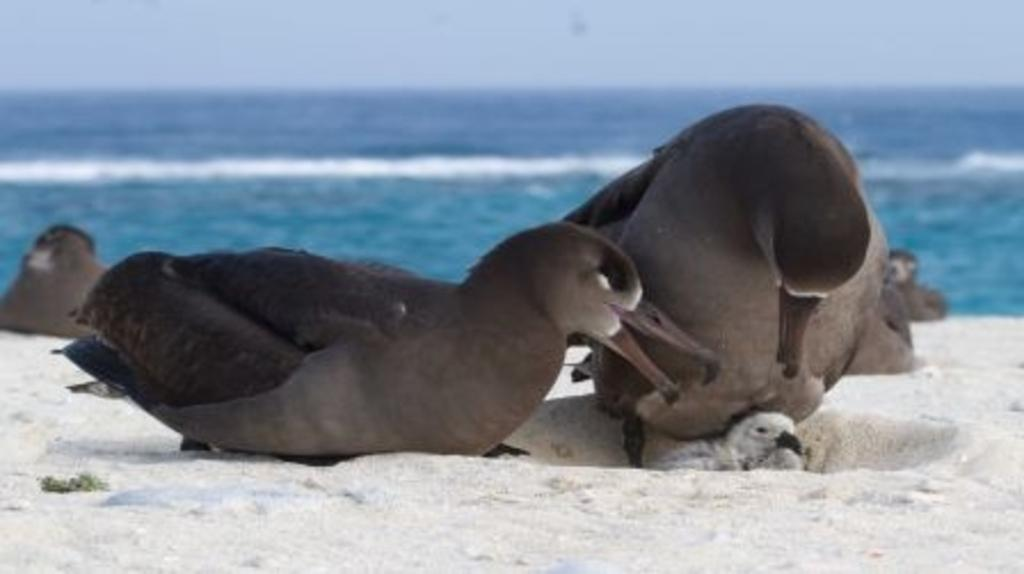What type of animals can be seen on the sand in the image? There are birds on the sand in the image. What colors are the birds in the image? The birds are in black, grey, and white colors. What can be seen in the background of the image? There is water and the sky visible in the background. What type of comb can be seen in the image? There is no comb present in the image; it features birds on the sand with a background of water and sky. 